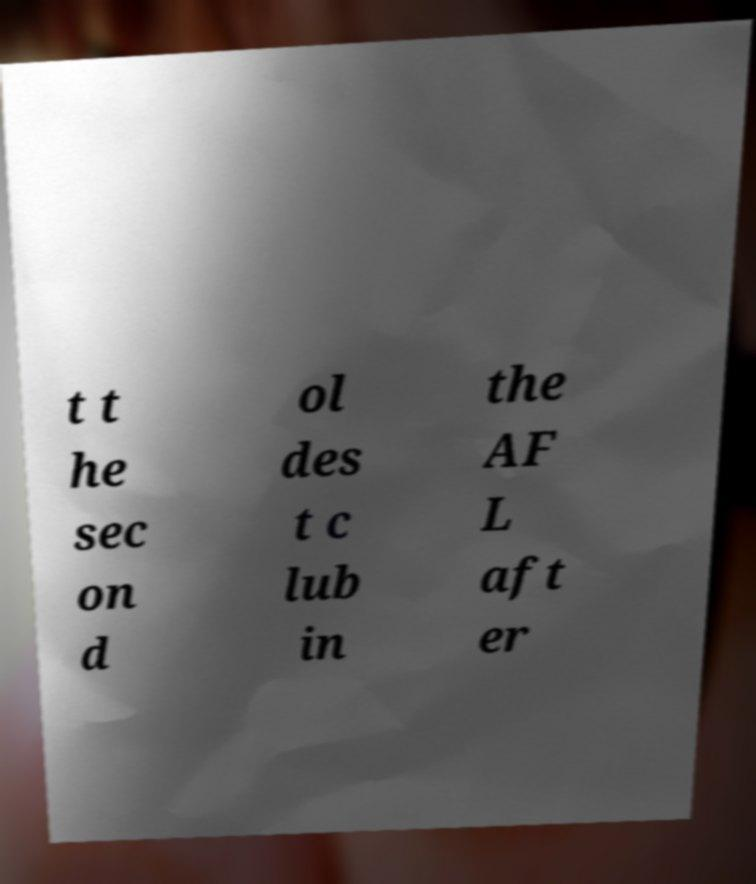Can you read and provide the text displayed in the image?This photo seems to have some interesting text. Can you extract and type it out for me? t t he sec on d ol des t c lub in the AF L aft er 